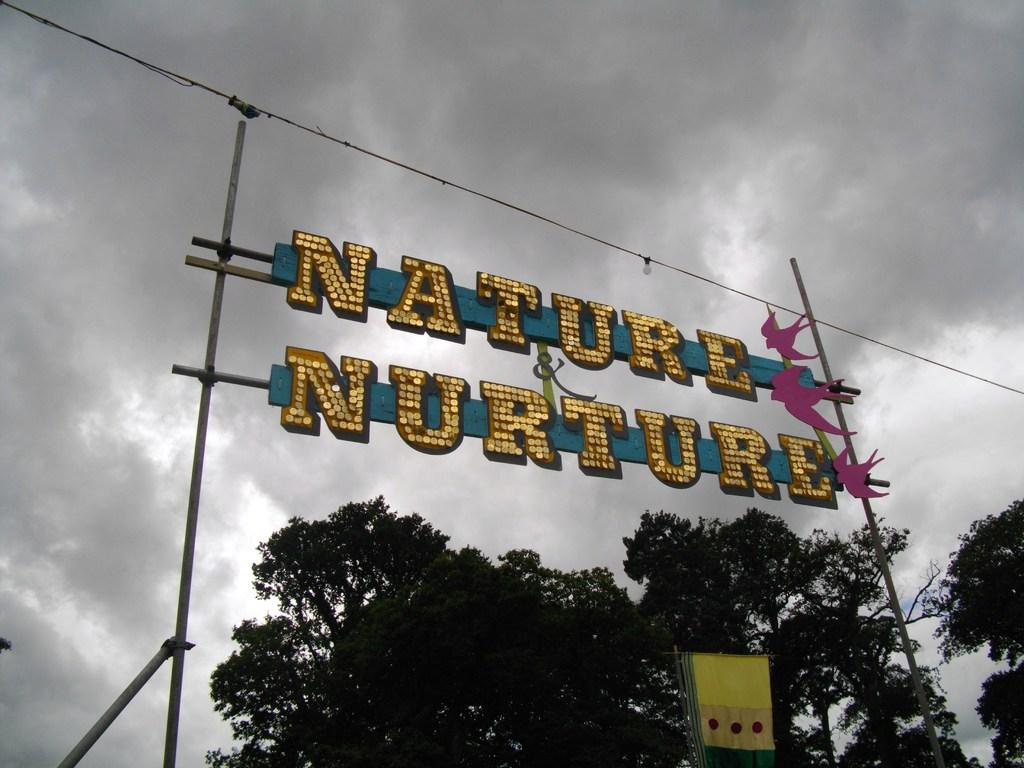What type of structures can be seen in the image? There are poles in the image. What is written or displayed on a board in the image? There is a board with text in the image. What type of handmade objects are visible in the image? There are paper crafts in the image. What is located at the bottom of the image? There is an object in the bottom of the image. What type of natural vegetation can be seen in the image? There are trees in the image. What type of utility is present in the image? There is a wire in the image. What is visible in the sky in the image? The sky is visible in the image, and clouds are present in the sky. What type of music can be heard playing in the background of the image? There is no music present in the image, as it is a still image and does not have any audio component. Can you describe the picture of a bird with a wing in the image? There is no picture of a bird with a wing in the image; the provided facts do not mention any such object. 